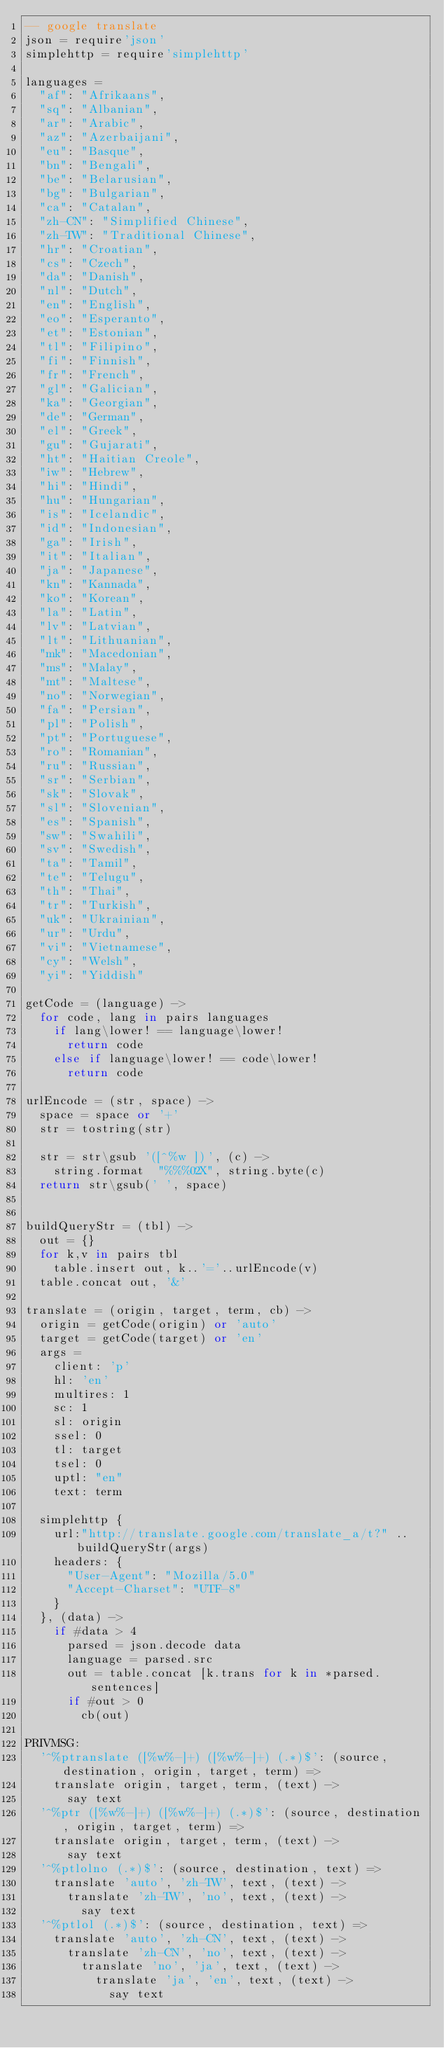Convert code to text. <code><loc_0><loc_0><loc_500><loc_500><_MoonScript_>-- google translate
json = require'json'
simplehttp = require'simplehttp'

languages =
  "af": "Afrikaans",
  "sq": "Albanian",
  "ar": "Arabic",
  "az": "Azerbaijani",
  "eu": "Basque",
  "bn": "Bengali",
  "be": "Belarusian",
  "bg": "Bulgarian",
  "ca": "Catalan",
  "zh-CN": "Simplified Chinese",
  "zh-TW": "Traditional Chinese",
  "hr": "Croatian",
  "cs": "Czech",
  "da": "Danish",
  "nl": "Dutch",
  "en": "English",
  "eo": "Esperanto",
  "et": "Estonian",
  "tl": "Filipino",
  "fi": "Finnish",
  "fr": "French",
  "gl": "Galician",
  "ka": "Georgian",
  "de": "German",
  "el": "Greek",
  "gu": "Gujarati",
  "ht": "Haitian Creole",
  "iw": "Hebrew",
  "hi": "Hindi",
  "hu": "Hungarian",
  "is": "Icelandic",
  "id": "Indonesian",
  "ga": "Irish",
  "it": "Italian",
  "ja": "Japanese",
  "kn": "Kannada",
  "ko": "Korean",
  "la": "Latin",
  "lv": "Latvian",
  "lt": "Lithuanian",
  "mk": "Macedonian",
  "ms": "Malay",
  "mt": "Maltese",
  "no": "Norwegian",
  "fa": "Persian",
  "pl": "Polish",
  "pt": "Portuguese",
  "ro": "Romanian",
  "ru": "Russian",
  "sr": "Serbian",
  "sk": "Slovak",
  "sl": "Slovenian",
  "es": "Spanish",
  "sw": "Swahili",
  "sv": "Swedish",
  "ta": "Tamil",
  "te": "Telugu",
  "th": "Thai",
  "tr": "Turkish",
  "uk": "Ukrainian",
  "ur": "Urdu",
  "vi": "Vietnamese",
  "cy": "Welsh",
  "yi": "Yiddish"

getCode = (language) ->
  for code, lang in pairs languages
    if lang\lower! == language\lower!
      return code
    else if language\lower! == code\lower!
      return code

urlEncode = (str, space) ->
  space = space or '+'
  str = tostring(str)

  str = str\gsub '([^%w ])', (c) ->
    string.format  "%%%02X", string.byte(c) 
  return str\gsub(' ', space)


buildQueryStr = (tbl) ->
  out = {}
  for k,v in pairs tbl
    table.insert out, k..'='..urlEncode(v)
  table.concat out, '&'

translate = (origin, target, term, cb) ->
  origin = getCode(origin) or 'auto'
  target = getCode(target) or 'en'
  args =
    client: 'p'
    hl: 'en'
    multires: 1
    sc: 1
    sl: origin
    ssel: 0
    tl: target
    tsel: 0
    uptl: "en"
    text: term

  simplehttp {
    url:"http://translate.google.com/translate_a/t?" .. buildQueryStr(args)
    headers: {
      "User-Agent": "Mozilla/5.0"
      "Accept-Charset": "UTF-8"
    }
  }, (data) ->
    if #data > 4
      parsed = json.decode data
      language = parsed.src
      out = table.concat [k.trans for k in *parsed.sentences]
      if #out > 0
        cb(out)

PRIVMSG:
  '^%ptranslate ([%w%-]+) ([%w%-]+) (.*)$': (source, destination, origin, target, term) =>
    translate origin, target, term, (text) ->
      say text
  '^%ptr ([%w%-]+) ([%w%-]+) (.*)$': (source, destination, origin, target, term) =>
    translate origin, target, term, (text) ->
      say text
  '^%ptlolno (.*)$': (source, destination, text) =>
    translate 'auto', 'zh-TW', text, (text) ->
      translate 'zh-TW', 'no', text, (text) ->
        say text
  '^%ptlol (.*)$': (source, destination, text) =>
    translate 'auto', 'zh-CN', text, (text) ->
      translate 'zh-CN', 'no', text, (text) ->
        translate 'no', 'ja', text, (text) ->
          translate 'ja', 'en', text, (text) ->
            say text
</code> 